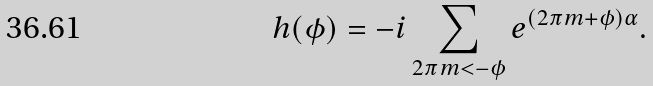<formula> <loc_0><loc_0><loc_500><loc_500>h ( \phi ) = - i \sum _ { 2 \pi m < - \phi } e ^ { ( 2 \pi m + \phi ) \alpha } .</formula> 